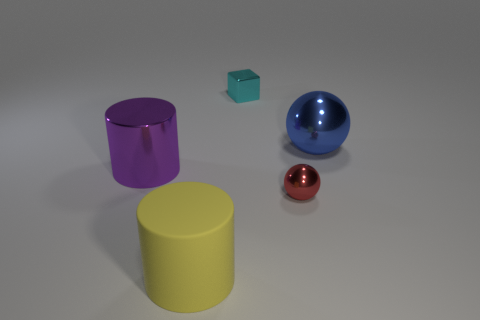Add 1 large cyan matte spheres. How many objects exist? 6 Subtract all red spheres. How many spheres are left? 1 Subtract all balls. How many objects are left? 3 Subtract 1 blocks. How many blocks are left? 0 Subtract all purple cylinders. Subtract all cyan blocks. How many cylinders are left? 1 Subtract all brown spheres. How many cyan cylinders are left? 0 Subtract all blue metallic spheres. Subtract all big purple cylinders. How many objects are left? 3 Add 2 purple shiny things. How many purple shiny things are left? 3 Add 1 tiny metallic things. How many tiny metallic things exist? 3 Subtract 0 gray blocks. How many objects are left? 5 